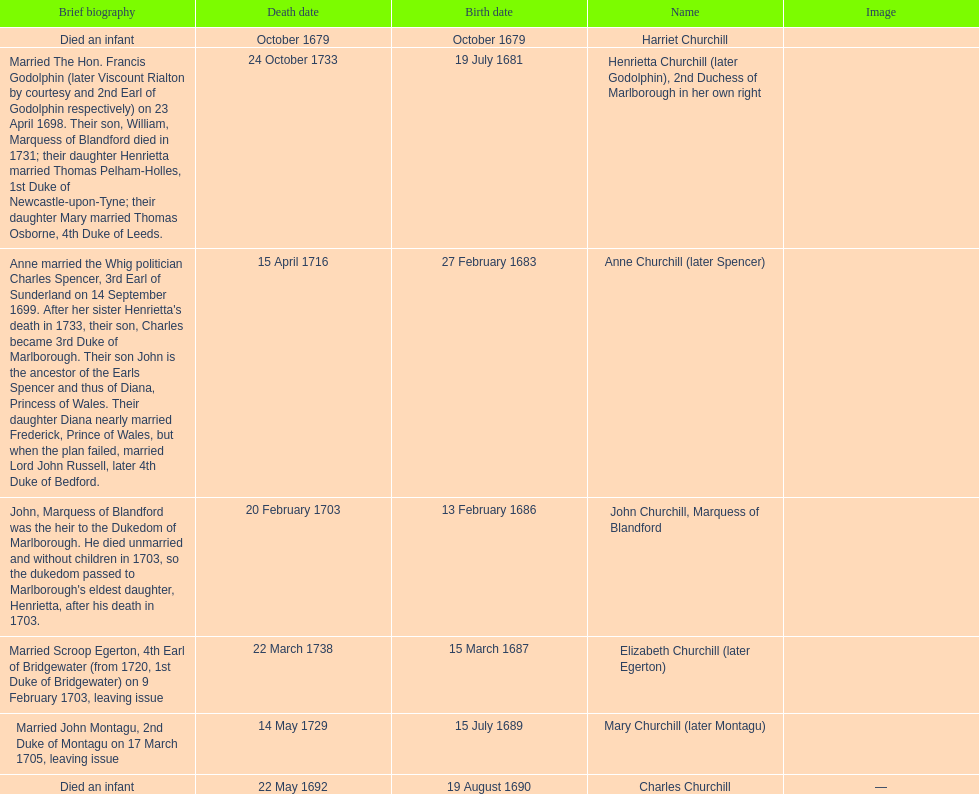What is the total number of children listed? 7. 